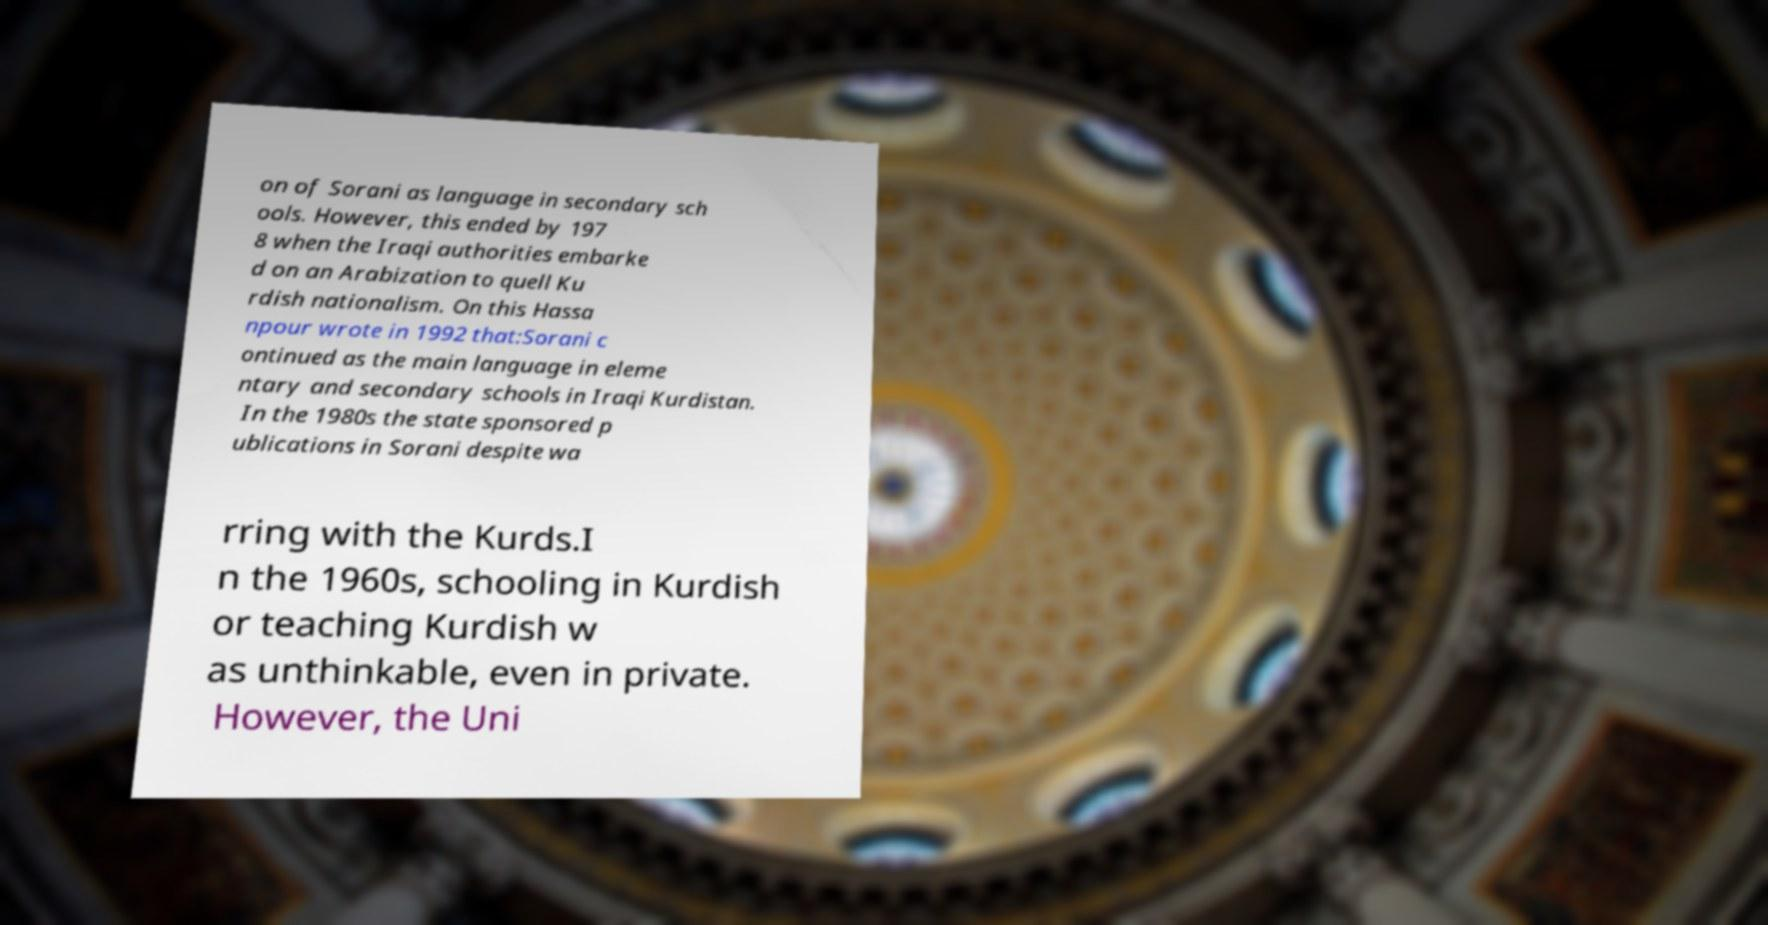Please identify and transcribe the text found in this image. on of Sorani as language in secondary sch ools. However, this ended by 197 8 when the Iraqi authorities embarke d on an Arabization to quell Ku rdish nationalism. On this Hassa npour wrote in 1992 that:Sorani c ontinued as the main language in eleme ntary and secondary schools in Iraqi Kurdistan. In the 1980s the state sponsored p ublications in Sorani despite wa rring with the Kurds.I n the 1960s, schooling in Kurdish or teaching Kurdish w as unthinkable, even in private. However, the Uni 